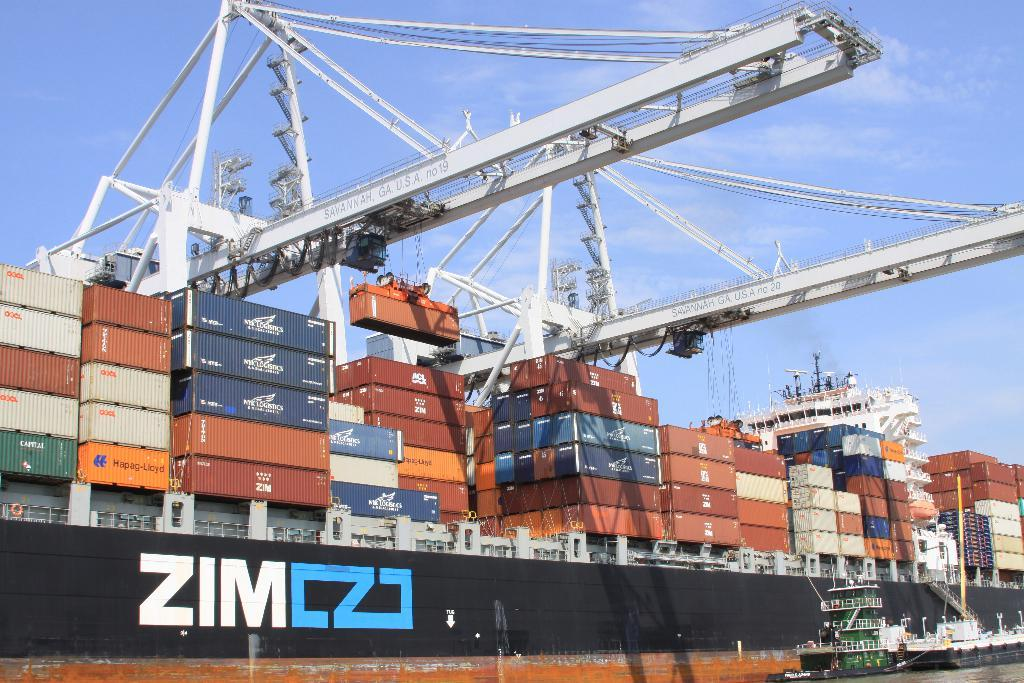What types of watercraft are in the image? There are ships and boats in the image. Where are the ships and boats located? They are on the water in the image. What other objects can be seen in the image? There are many containers and cranes in the image. Can you describe the relationship between the boat and the ship in the image? There is a boat in a ship in the image. What is visible in the background of the image? Clouds and the sky are visible in the background of the image. What type of gold design can be seen on the boat in the image? There is no gold design present on the boat in the image. What season is it in the image? The provided facts do not mention the season, so it cannot be determined from the image. 